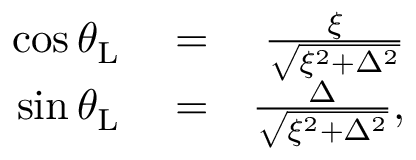Convert formula to latex. <formula><loc_0><loc_0><loc_500><loc_500>\begin{array} { r l r } { \cos \theta _ { L } } & = } & { \frac { \xi } { \sqrt { \xi ^ { 2 } + \Delta ^ { 2 } } } } \\ { \sin \theta _ { L } } & = } & { \frac { \Delta } { \sqrt { \xi ^ { 2 } + \Delta ^ { 2 } } } , } \end{array}</formula> 